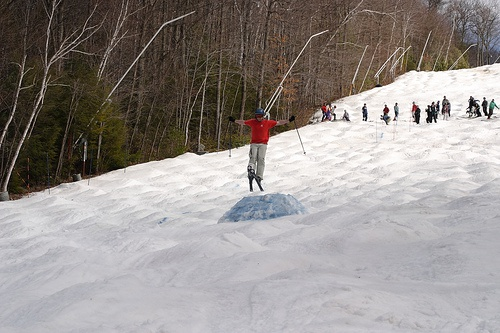Describe the objects in this image and their specific colors. I can see people in black, white, gray, and darkgray tones, people in black, brown, gray, maroon, and darkgray tones, people in black, white, gray, and teal tones, people in black, darkgray, lightgray, and gray tones, and people in black, maroon, gray, and brown tones in this image. 